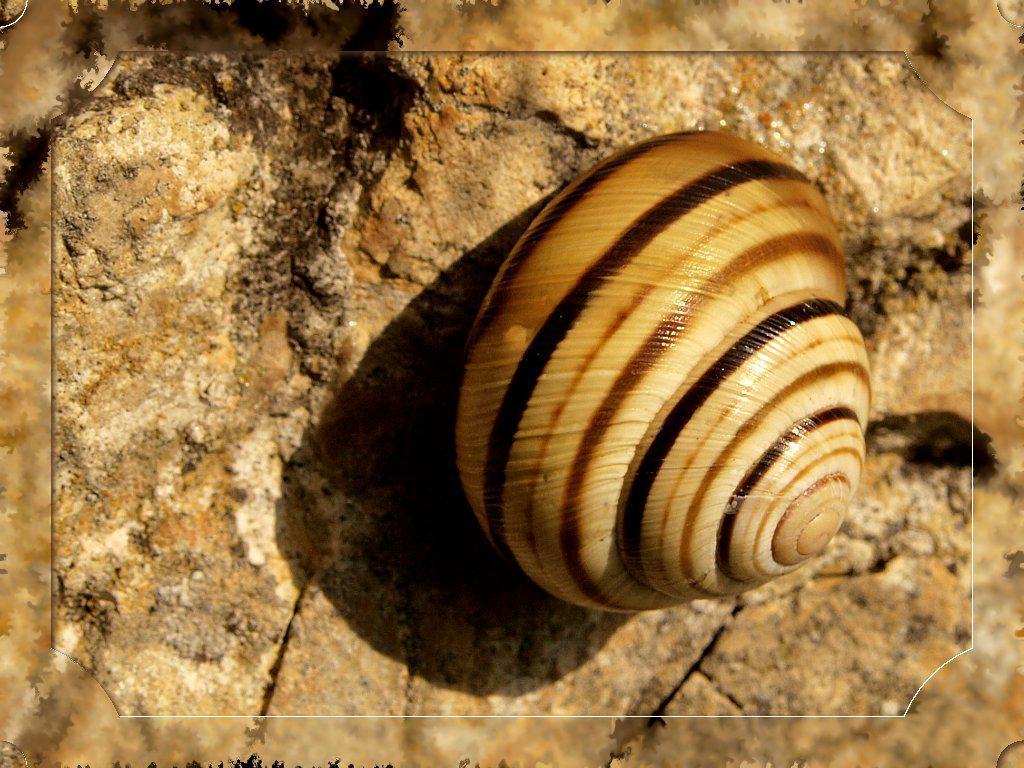Describe this image in one or two sentences. In the foreground of this edited image, there is a shell on the stone surface. 